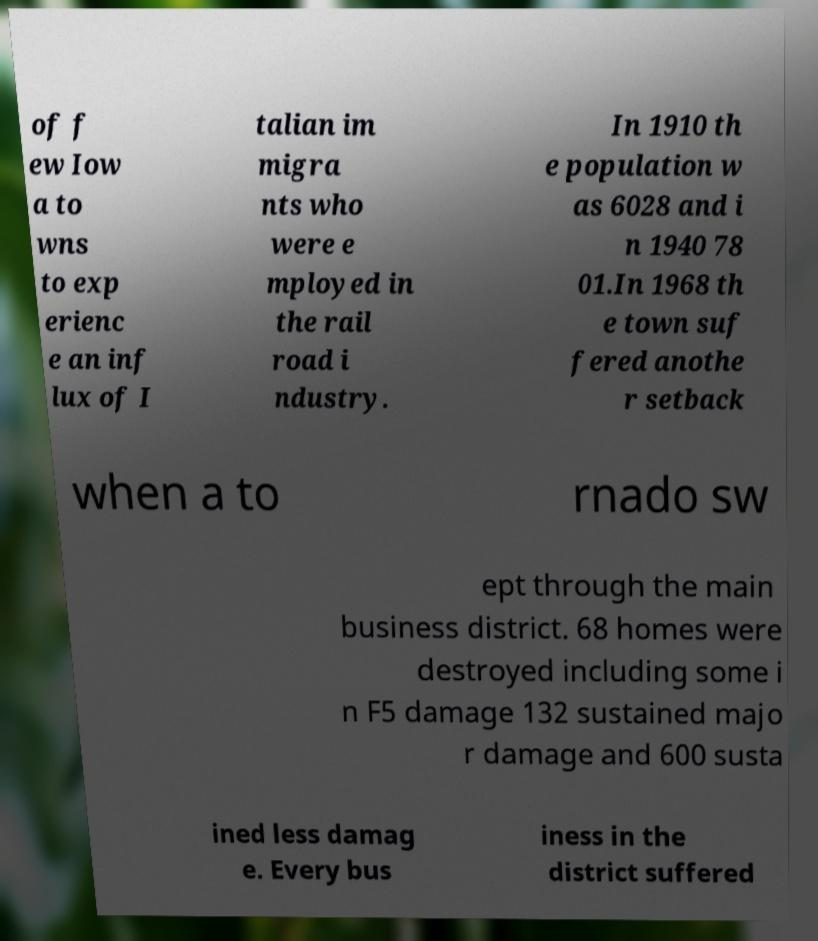For documentation purposes, I need the text within this image transcribed. Could you provide that? of f ew Iow a to wns to exp erienc e an inf lux of I talian im migra nts who were e mployed in the rail road i ndustry. In 1910 th e population w as 6028 and i n 1940 78 01.In 1968 th e town suf fered anothe r setback when a to rnado sw ept through the main business district. 68 homes were destroyed including some i n F5 damage 132 sustained majo r damage and 600 susta ined less damag e. Every bus iness in the district suffered 